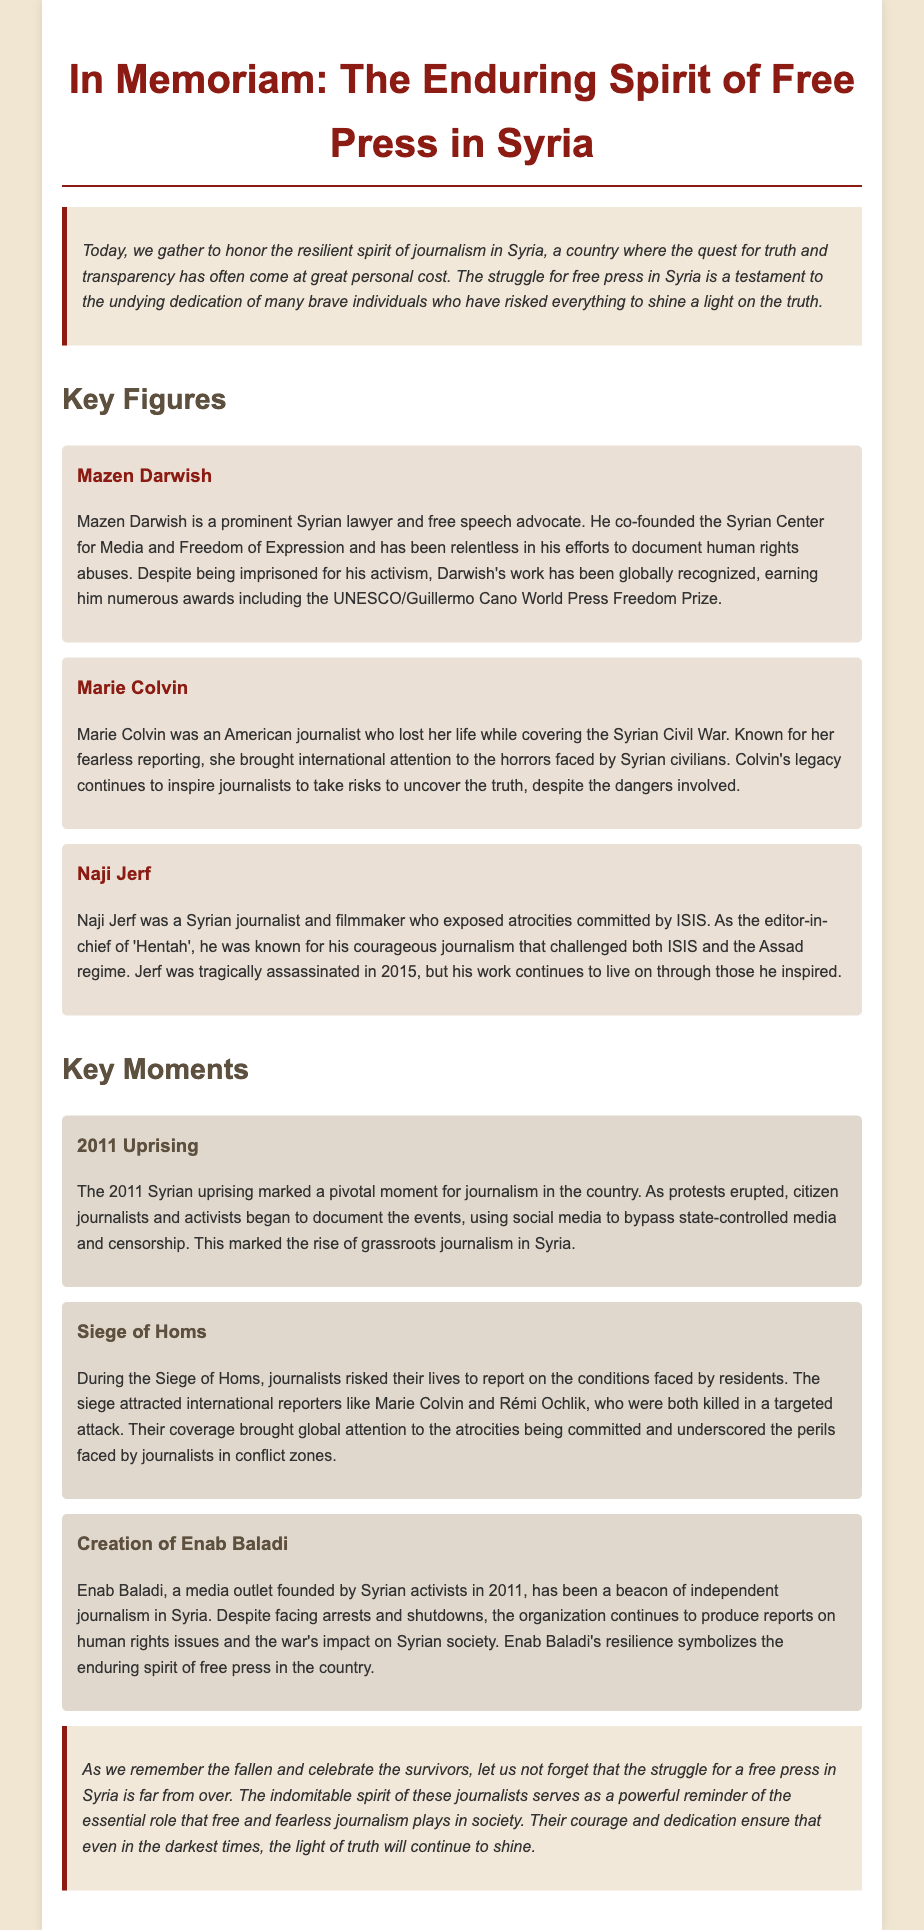what is the name of the prominent Syrian lawyer mentioned? The prominent Syrian lawyer and free speech advocate mentioned in the eulogy is Mazen Darwish.
Answer: Mazen Darwish which American journalist was killed while covering the Syrian Civil War? The American journalist who lost her life while covering the Syrian Civil War is Marie Colvin.
Answer: Marie Colvin what year did the Syrian uprising begin? The year when the Syrian uprising marked a pivotal moment for journalism was 2011.
Answer: 2011 who was the editor-in-chief of 'Hentah'? The editor-in-chief of 'Hentah' was Naji Jerf, known for his courageous journalism.
Answer: Naji Jerf what media outlet was founded by Syrian activists in 2011? The media outlet founded by Syrian activists in 2011 is Enab Baladi.
Answer: Enab Baladi who were the journalists killed during the Siege of Homs? The journalists killed during the Siege of Homs were Marie Colvin and Rémi Ochlik.
Answer: Marie Colvin and Rémi Ochlik what award did Mazen Darwish receive for his efforts? Mazen Darwish has received numerous awards, including the UNESCO/Guillermo Cano World Press Freedom Prize.
Answer: UNESCO/Guillermo Cano World Press Freedom Prize which event prompted the rise of grassroots journalism in Syria? The event that marked the rise of grassroots journalism in Syria was the 2011 uprising.
Answer: 2011 uprising what is the purpose of the eulogy? The purpose of the eulogy is to honor the resilient spirit of journalism in Syria and the individuals involved in the struggle for press freedom.
Answer: To honor the resilient spirit of journalism in Syria 